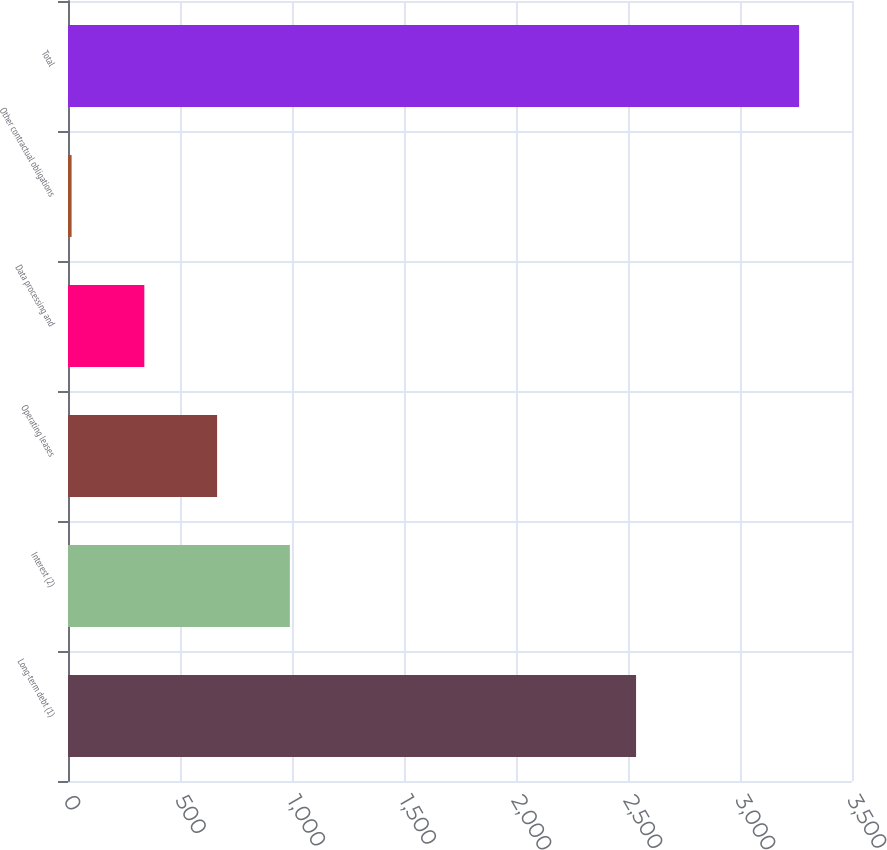<chart> <loc_0><loc_0><loc_500><loc_500><bar_chart><fcel>Long-term debt (1)<fcel>Interest (2)<fcel>Operating leases<fcel>Data processing and<fcel>Other contractual obligations<fcel>Total<nl><fcel>2536<fcel>990.4<fcel>665.6<fcel>340.8<fcel>16<fcel>3264<nl></chart> 